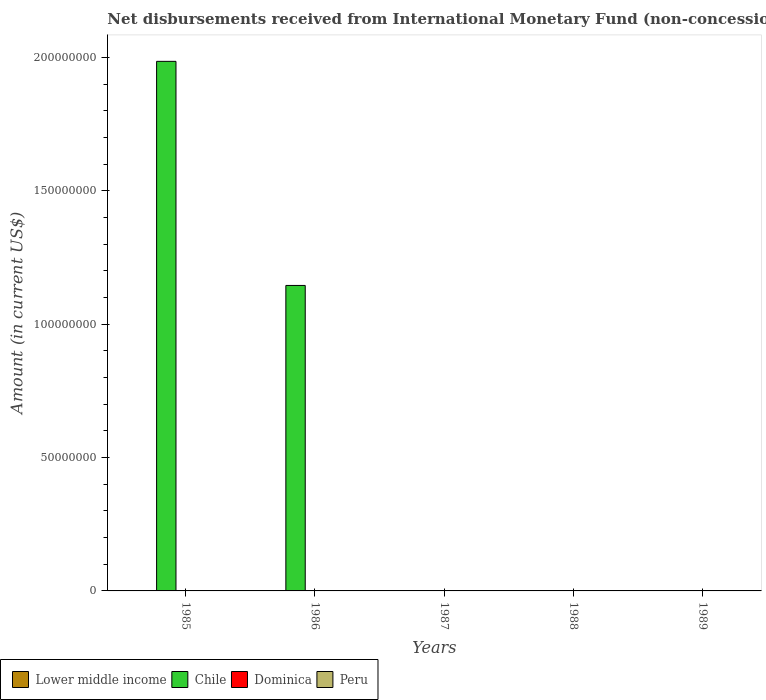How many different coloured bars are there?
Make the answer very short. 1. How many bars are there on the 1st tick from the left?
Keep it short and to the point. 1. How many bars are there on the 1st tick from the right?
Offer a terse response. 0. What is the label of the 5th group of bars from the left?
Provide a succinct answer. 1989. In how many cases, is the number of bars for a given year not equal to the number of legend labels?
Your answer should be very brief. 5. What is the amount of disbursements received from International Monetary Fund in Peru in 1986?
Ensure brevity in your answer.  0. Across all years, what is the maximum amount of disbursements received from International Monetary Fund in Chile?
Provide a succinct answer. 1.99e+08. Across all years, what is the minimum amount of disbursements received from International Monetary Fund in Peru?
Offer a very short reply. 0. In which year was the amount of disbursements received from International Monetary Fund in Chile maximum?
Provide a short and direct response. 1985. What is the difference between the amount of disbursements received from International Monetary Fund in Chile in 1985 and that in 1986?
Provide a short and direct response. 8.40e+07. In how many years, is the amount of disbursements received from International Monetary Fund in Peru greater than 60000000 US$?
Keep it short and to the point. 0. What is the difference between the highest and the lowest amount of disbursements received from International Monetary Fund in Chile?
Your answer should be compact. 1.99e+08. Is it the case that in every year, the sum of the amount of disbursements received from International Monetary Fund in Chile and amount of disbursements received from International Monetary Fund in Lower middle income is greater than the sum of amount of disbursements received from International Monetary Fund in Dominica and amount of disbursements received from International Monetary Fund in Peru?
Provide a succinct answer. No. How many years are there in the graph?
Your response must be concise. 5. What is the difference between two consecutive major ticks on the Y-axis?
Ensure brevity in your answer.  5.00e+07. Are the values on the major ticks of Y-axis written in scientific E-notation?
Give a very brief answer. No. Does the graph contain grids?
Offer a very short reply. No. How many legend labels are there?
Keep it short and to the point. 4. What is the title of the graph?
Provide a short and direct response. Net disbursements received from International Monetary Fund (non-concessional). What is the label or title of the X-axis?
Offer a very short reply. Years. What is the label or title of the Y-axis?
Make the answer very short. Amount (in current US$). What is the Amount (in current US$) in Chile in 1985?
Give a very brief answer. 1.99e+08. What is the Amount (in current US$) of Peru in 1985?
Give a very brief answer. 0. What is the Amount (in current US$) in Chile in 1986?
Provide a short and direct response. 1.15e+08. What is the Amount (in current US$) of Lower middle income in 1987?
Keep it short and to the point. 0. What is the Amount (in current US$) in Dominica in 1987?
Offer a very short reply. 0. What is the Amount (in current US$) of Peru in 1987?
Your response must be concise. 0. What is the Amount (in current US$) in Peru in 1988?
Provide a succinct answer. 0. What is the Amount (in current US$) in Chile in 1989?
Provide a succinct answer. 0. Across all years, what is the maximum Amount (in current US$) of Chile?
Your answer should be very brief. 1.99e+08. Across all years, what is the minimum Amount (in current US$) in Chile?
Your response must be concise. 0. What is the total Amount (in current US$) of Lower middle income in the graph?
Provide a short and direct response. 0. What is the total Amount (in current US$) in Chile in the graph?
Your answer should be compact. 3.13e+08. What is the total Amount (in current US$) of Dominica in the graph?
Make the answer very short. 0. What is the difference between the Amount (in current US$) in Chile in 1985 and that in 1986?
Your answer should be compact. 8.40e+07. What is the average Amount (in current US$) in Chile per year?
Make the answer very short. 6.26e+07. What is the average Amount (in current US$) of Dominica per year?
Offer a terse response. 0. What is the average Amount (in current US$) in Peru per year?
Ensure brevity in your answer.  0. What is the ratio of the Amount (in current US$) of Chile in 1985 to that in 1986?
Your answer should be compact. 1.73. What is the difference between the highest and the lowest Amount (in current US$) of Chile?
Your answer should be very brief. 1.99e+08. 